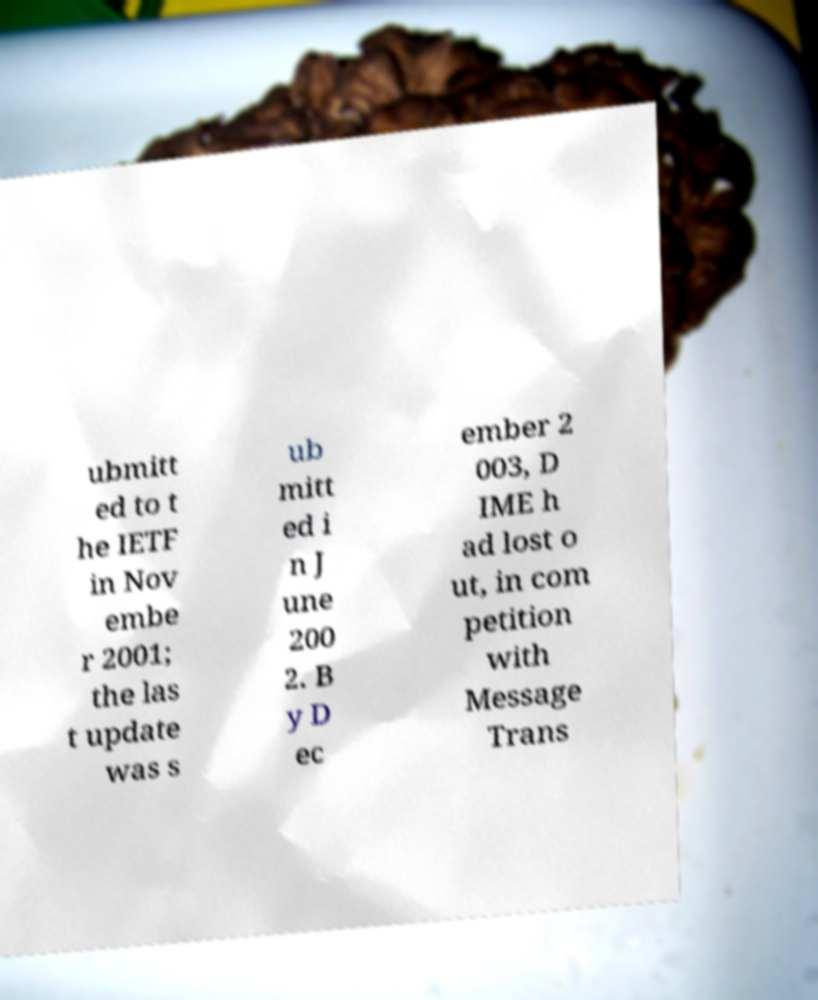Please identify and transcribe the text found in this image. ubmitt ed to t he IETF in Nov embe r 2001; the las t update was s ub mitt ed i n J une 200 2. B y D ec ember 2 003, D IME h ad lost o ut, in com petition with Message Trans 